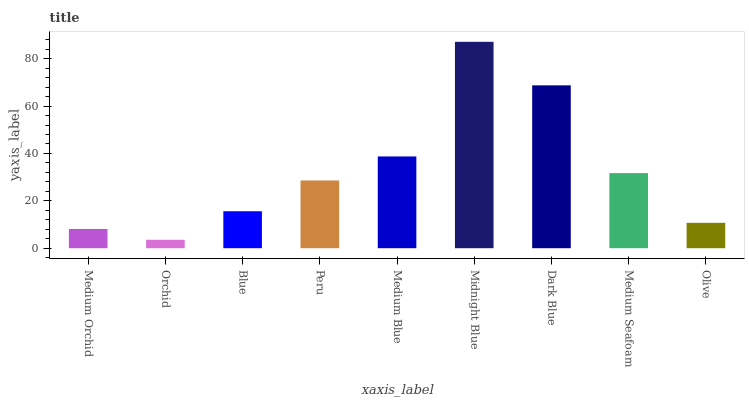Is Orchid the minimum?
Answer yes or no. Yes. Is Midnight Blue the maximum?
Answer yes or no. Yes. Is Blue the minimum?
Answer yes or no. No. Is Blue the maximum?
Answer yes or no. No. Is Blue greater than Orchid?
Answer yes or no. Yes. Is Orchid less than Blue?
Answer yes or no. Yes. Is Orchid greater than Blue?
Answer yes or no. No. Is Blue less than Orchid?
Answer yes or no. No. Is Peru the high median?
Answer yes or no. Yes. Is Peru the low median?
Answer yes or no. Yes. Is Midnight Blue the high median?
Answer yes or no. No. Is Dark Blue the low median?
Answer yes or no. No. 